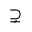Convert formula to latex. <formula><loc_0><loc_0><loc_500><loc_500>\supsetneq</formula> 